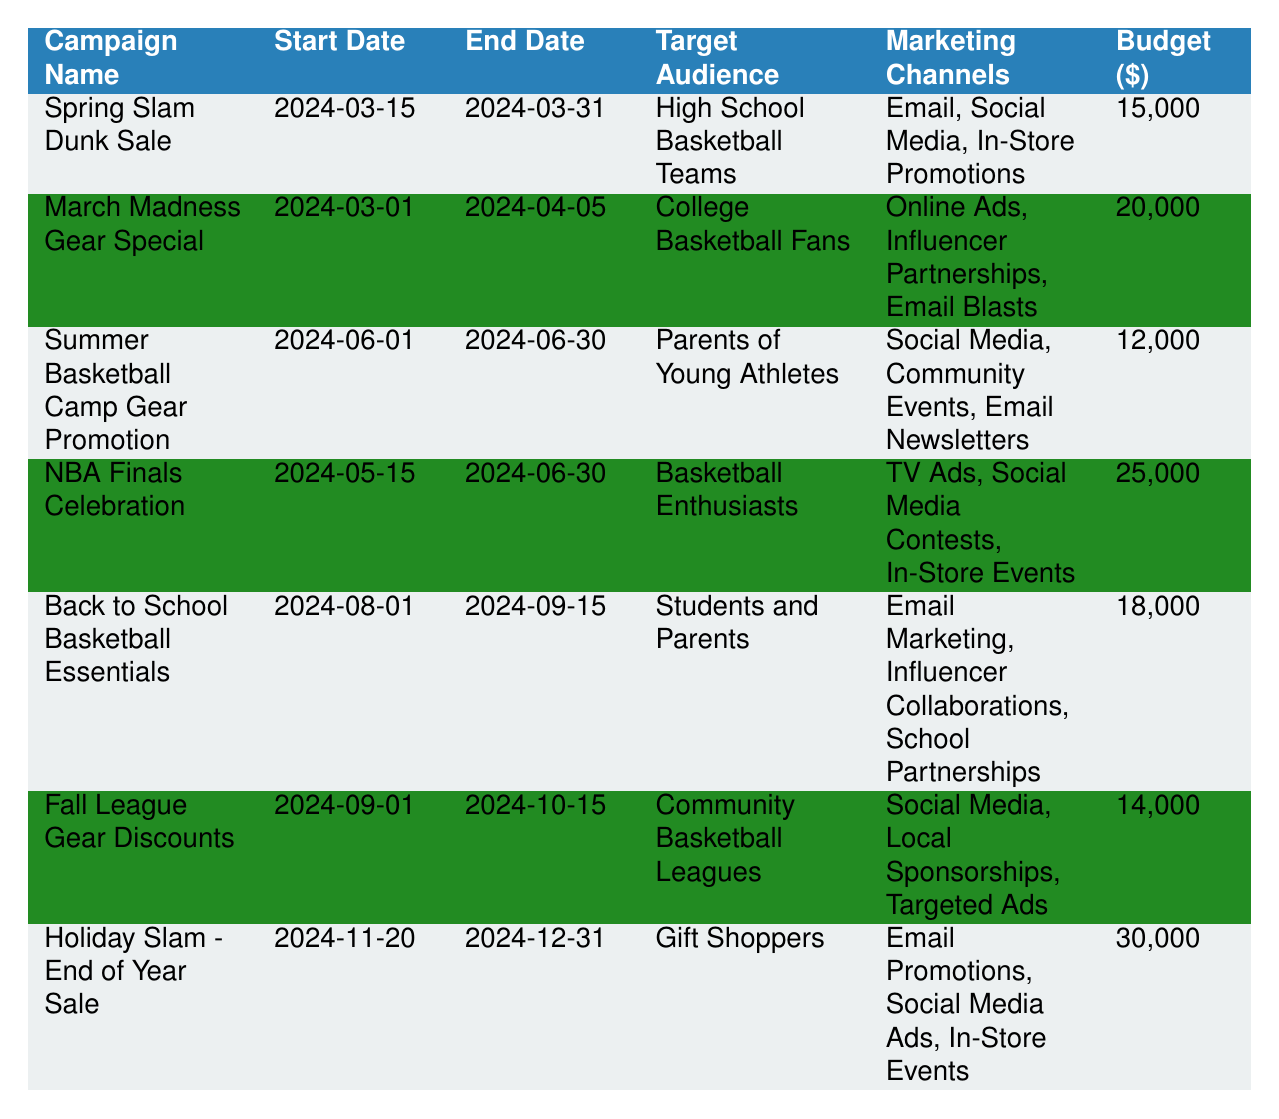What is the budget allocated for the Holiday Slam - End of Year Sale? The table shows the details for each campaign, and under the budget column for the "Holiday Slam - End of Year Sale," it lists the budget as 30000.
Answer: 30000 Which campaign is targeting parents of young athletes? By scanning the target audience column, it is clear that the campaign named "Summer Basketball Camp Gear Promotion" is aimed at parents of young athletes.
Answer: Summer Basketball Camp Gear Promotion How many total campaigns are scheduled for the month of March? Reviewing the start and end dates of each campaign, two campaigns, "Spring Slam Dunk Sale" (starting on March 15) and "March Madness Gear Special" (starting on March 1), fall within the month of March.
Answer: 2 What is the difference in budget between the NBA Finals Celebration and the Fall League Gear Discounts? The NBA Finals Celebration has a budget of 25000, while the Fall League Gear Discounts has a budget of 14000. The difference is calculated as 25000 - 14000 = 11000.
Answer: 11000 Is the March Madness Gear Special campaign targeting gift shoppers? The table shows that the target audience for the "March Madness Gear Special" campaign is College Basketball Fans, not gift shoppers. Therefore, the answer is no.
Answer: No Which campaign has the longest duration, and what is that duration? By comparing the start and end dates: "March Madness Gear Special" runs from March 1 to April 5 (36 days), "NBA Finals Celebration" from May 15 to June 30 (46 days), and "Holiday Slam - End of Year Sale" from November 20 to December 31 (42 days). Among these, the "NBA Finals Celebration" has the longest duration.
Answer: NBA Finals Celebration, 46 days Calculate the average budget of all campaigns scheduled in 2024. The budgets of the campaigns are 15000, 20000, 12000, 25000, 18000, 14000, and 30000. Summing those gives 114000. Since there are 7 campaigns, the average budget is 114000 / 7 = 16285.71, rounded to 16286.
Answer: 16286 How many campaigns are scheduled to start in the second half of the year (July to December)? The campaigns scheduled in that period are "Back to School Basketball Essentials," "Fall League Gear Discounts," and "Holiday Slam - End of Year Sale," totaling three campaigns.
Answer: 3 